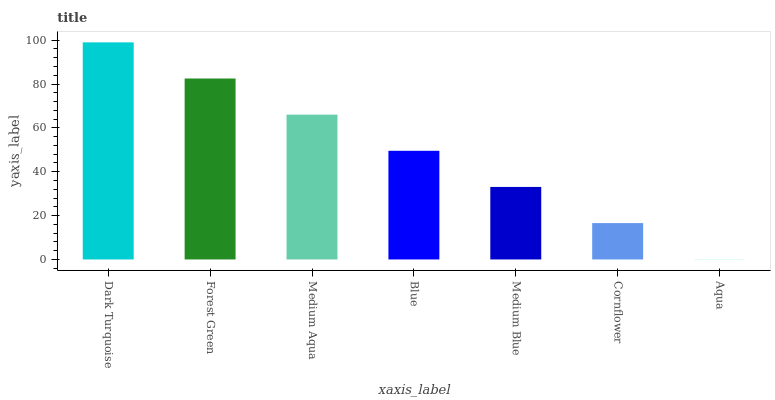Is Aqua the minimum?
Answer yes or no. Yes. Is Dark Turquoise the maximum?
Answer yes or no. Yes. Is Forest Green the minimum?
Answer yes or no. No. Is Forest Green the maximum?
Answer yes or no. No. Is Dark Turquoise greater than Forest Green?
Answer yes or no. Yes. Is Forest Green less than Dark Turquoise?
Answer yes or no. Yes. Is Forest Green greater than Dark Turquoise?
Answer yes or no. No. Is Dark Turquoise less than Forest Green?
Answer yes or no. No. Is Blue the high median?
Answer yes or no. Yes. Is Blue the low median?
Answer yes or no. Yes. Is Forest Green the high median?
Answer yes or no. No. Is Medium Aqua the low median?
Answer yes or no. No. 